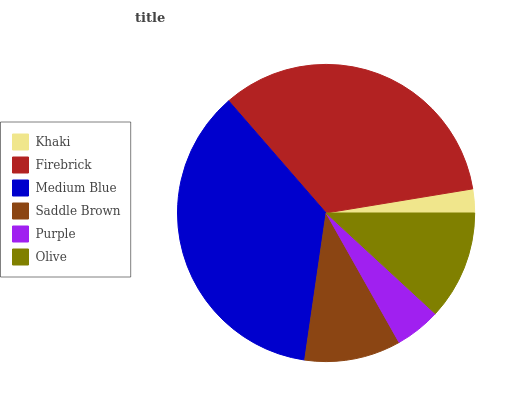Is Khaki the minimum?
Answer yes or no. Yes. Is Medium Blue the maximum?
Answer yes or no. Yes. Is Firebrick the minimum?
Answer yes or no. No. Is Firebrick the maximum?
Answer yes or no. No. Is Firebrick greater than Khaki?
Answer yes or no. Yes. Is Khaki less than Firebrick?
Answer yes or no. Yes. Is Khaki greater than Firebrick?
Answer yes or no. No. Is Firebrick less than Khaki?
Answer yes or no. No. Is Olive the high median?
Answer yes or no. Yes. Is Saddle Brown the low median?
Answer yes or no. Yes. Is Firebrick the high median?
Answer yes or no. No. Is Purple the low median?
Answer yes or no. No. 